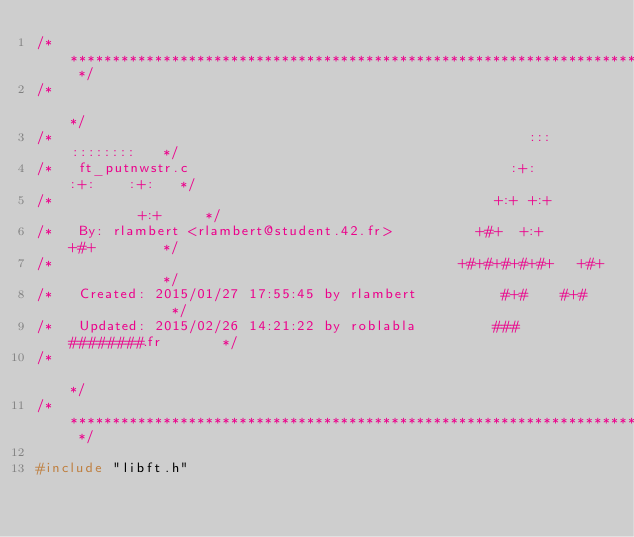Convert code to text. <code><loc_0><loc_0><loc_500><loc_500><_C_>/* ************************************************************************** */
/*                                                                            */
/*                                                        :::      ::::::::   */
/*   ft_putnwstr.c                                      :+:      :+:    :+:   */
/*                                                    +:+ +:+         +:+     */
/*   By: rlambert <rlambert@student.42.fr>          +#+  +:+       +#+        */
/*                                                +#+#+#+#+#+   +#+           */
/*   Created: 2015/01/27 17:55:45 by rlambert          #+#    #+#             */
/*   Updated: 2015/02/26 14:21:22 by roblabla         ###   ########.fr       */
/*                                                                            */
/* ************************************************************************** */

#include "libft.h"
</code> 